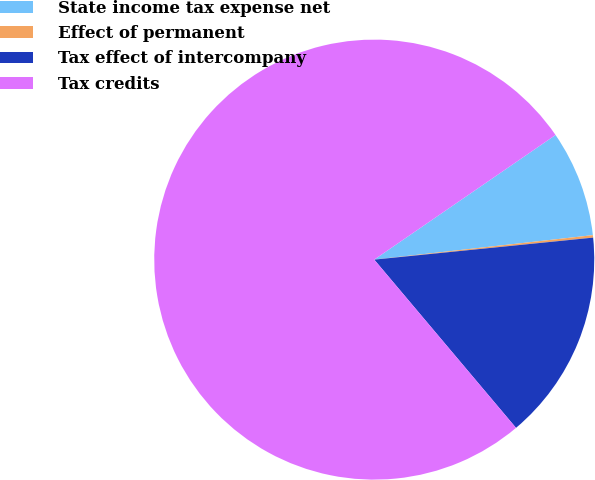<chart> <loc_0><loc_0><loc_500><loc_500><pie_chart><fcel>State income tax expense net<fcel>Effect of permanent<fcel>Tax effect of intercompany<fcel>Tax credits<nl><fcel>7.81%<fcel>0.18%<fcel>15.45%<fcel>76.56%<nl></chart> 